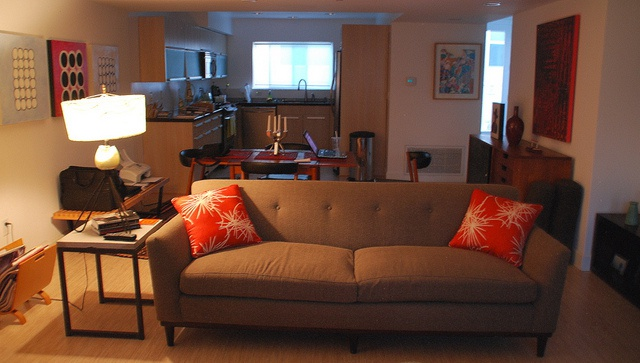Describe the objects in this image and their specific colors. I can see couch in tan, black, maroon, and brown tones, suitcase in tan, black, maroon, brown, and red tones, dining table in tan, maroon, black, and gray tones, chair in tan, black, maroon, and gray tones, and refrigerator in tan, black, and gray tones in this image. 